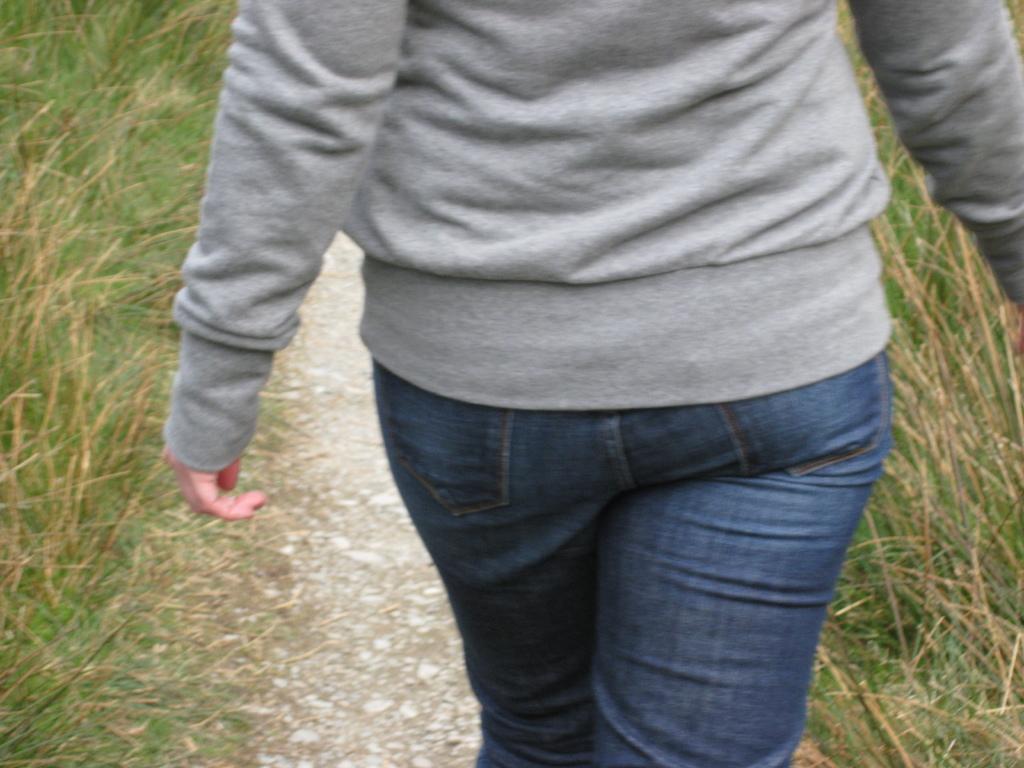Describe this image in one or two sentences. This picture is clicked outside. In the center we can see a person wearing grey color t-shirt and walking on the ground. On both the sides we can see the grass. 